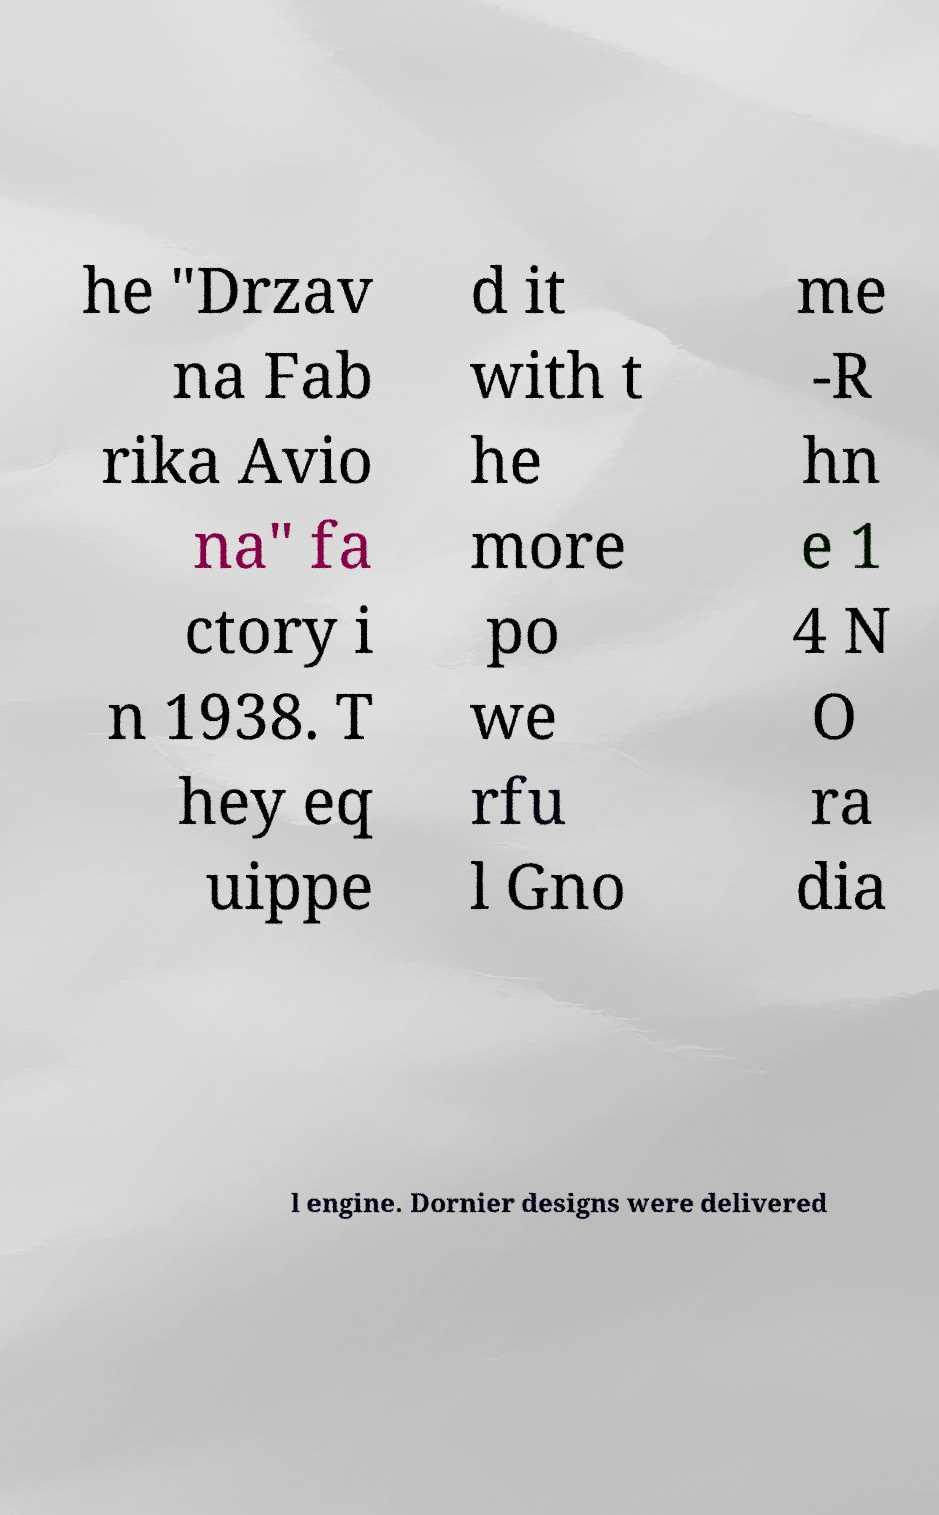Can you accurately transcribe the text from the provided image for me? he "Drzav na Fab rika Avio na" fa ctory i n 1938. T hey eq uippe d it with t he more po we rfu l Gno me -R hn e 1 4 N O ra dia l engine. Dornier designs were delivered 